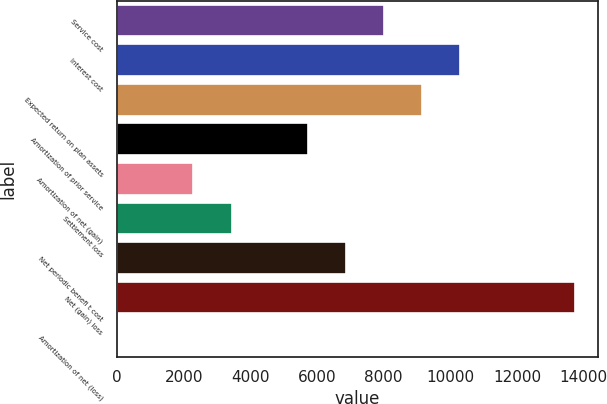<chart> <loc_0><loc_0><loc_500><loc_500><bar_chart><fcel>Service cost<fcel>Interest cost<fcel>Expected return on plan assets<fcel>Amortization of prior service<fcel>Amortization of net (gain)<fcel>Settlement loss<fcel>Net periodic benefi t cost<fcel>Net (gain) loss<fcel>Amortization of net (loss)<nl><fcel>8014.73<fcel>10304.2<fcel>9159.48<fcel>5725.23<fcel>2290.98<fcel>3435.73<fcel>6869.98<fcel>13738.5<fcel>1.48<nl></chart> 